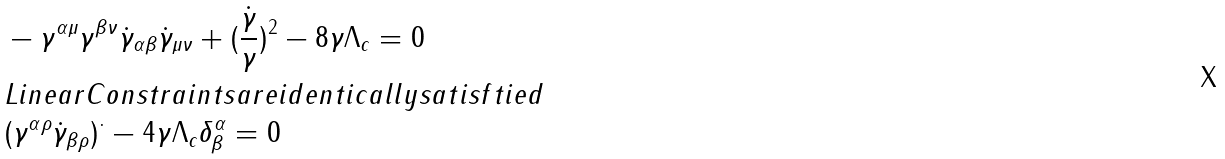<formula> <loc_0><loc_0><loc_500><loc_500>& - \gamma ^ { \alpha \mu } \gamma ^ { \beta \nu } \dot { \gamma } _ { \alpha \beta } \dot { \gamma } _ { \mu \nu } + ( \frac { \dot { \gamma } } { \gamma } ) ^ { 2 } - 8 \gamma \Lambda _ { c } = 0 \\ & L i n e a r C o n s t r a i n t s a r e i d e n t i c a l l y s a t i s f t i e d \\ & ( \gamma ^ { \alpha \rho } \dot { \gamma } _ { \beta \rho } ) ^ { \cdot } - 4 \gamma \Lambda _ { c } \delta ^ { \alpha } _ { \beta } = 0</formula> 